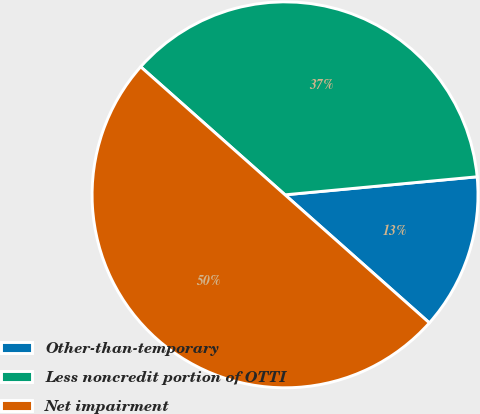Convert chart. <chart><loc_0><loc_0><loc_500><loc_500><pie_chart><fcel>Other-than-temporary<fcel>Less noncredit portion of OTTI<fcel>Net impairment<nl><fcel>13.04%<fcel>36.96%<fcel>50.0%<nl></chart> 